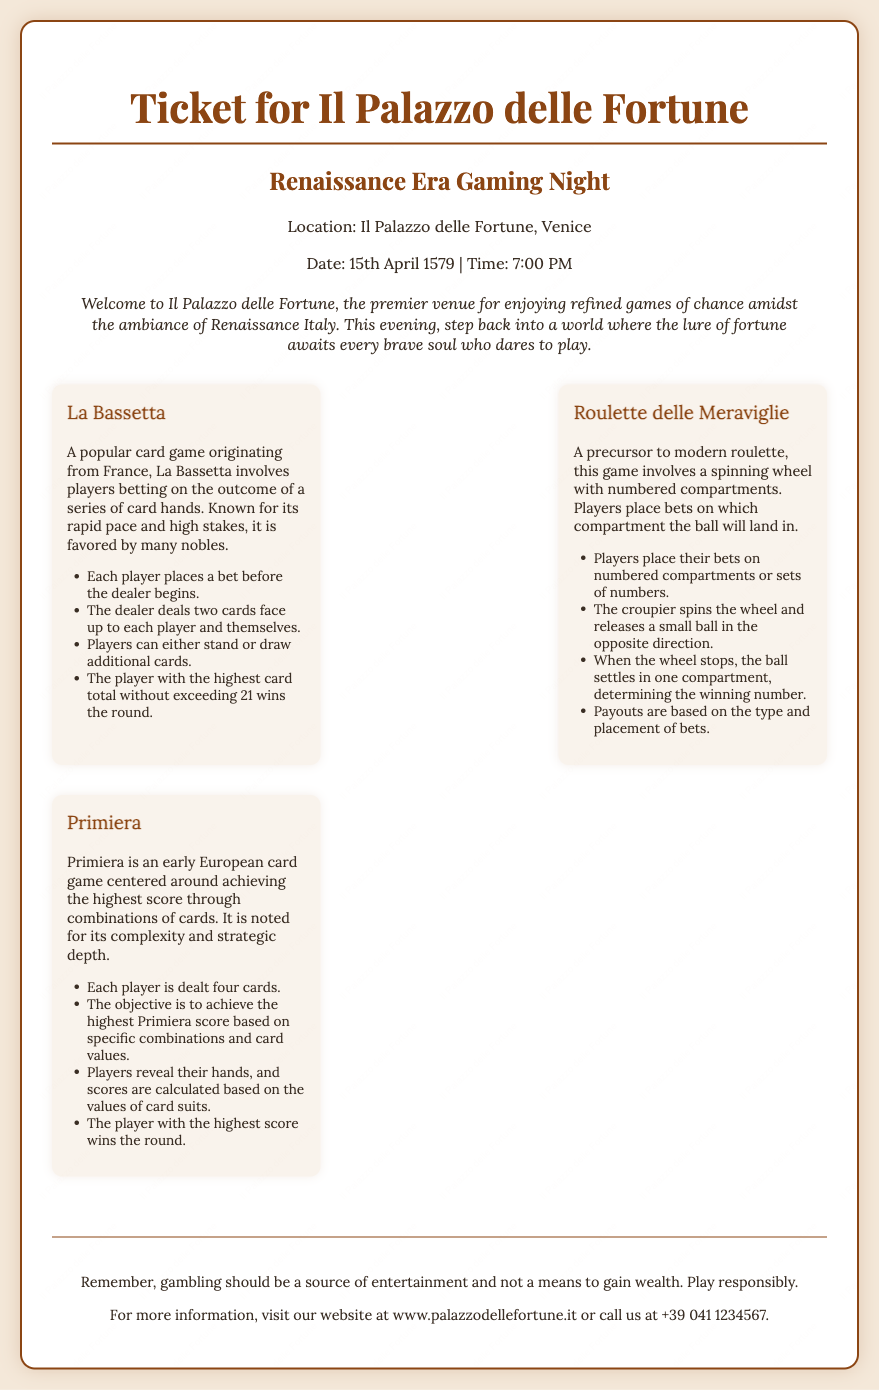What is the title of the ticket? The title of the ticket is prominently displayed at the top of the document.
Answer: Ticket for Il Palazzo delle Fortune What is the location of the gaming night? The location is mentioned in the header section of the document.
Answer: Il Palazzo delle Fortune, Venice What date is the gaming night scheduled for? The date of the event is provided in the header section along with the time.
Answer: 15th April 1579 What time does the gaming night start? The time of the event is located in the header section of the ticket.
Answer: 7:00 PM What is one of the games listed in the document? The document contains several games, each with a header.
Answer: La Bassetta What type of game is Roulette delle Meraviglie? The description of Roulette delle Meraviglie indicates its nature as a game.
Answer: Spinning wheel game How many cards are dealt in Primiera? The rules for Primiera specify the number of cards dealt to each player.
Answer: Four cards What does the footer advise about gambling? The footer contains important advice regarding responsible gambling.
Answer: Play responsibly Who can you contact for more information? The footer provides a contact detail for further inquiries.
Answer: +39 041 1234567 